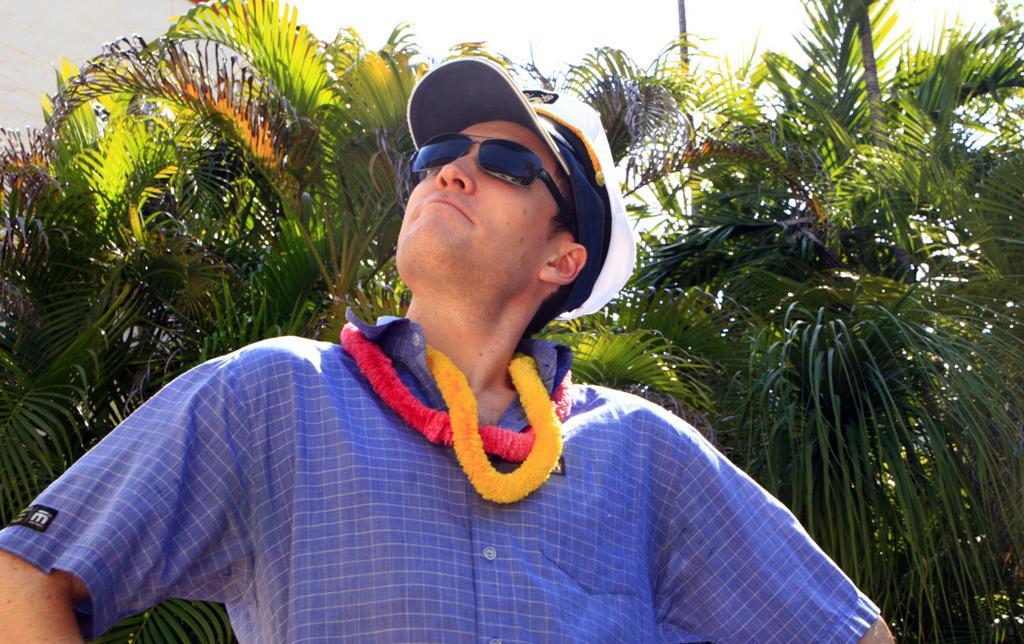Can you describe this image briefly? In the image in the center, we can see one person and he is wearing a cap. In the background we can see trees. 